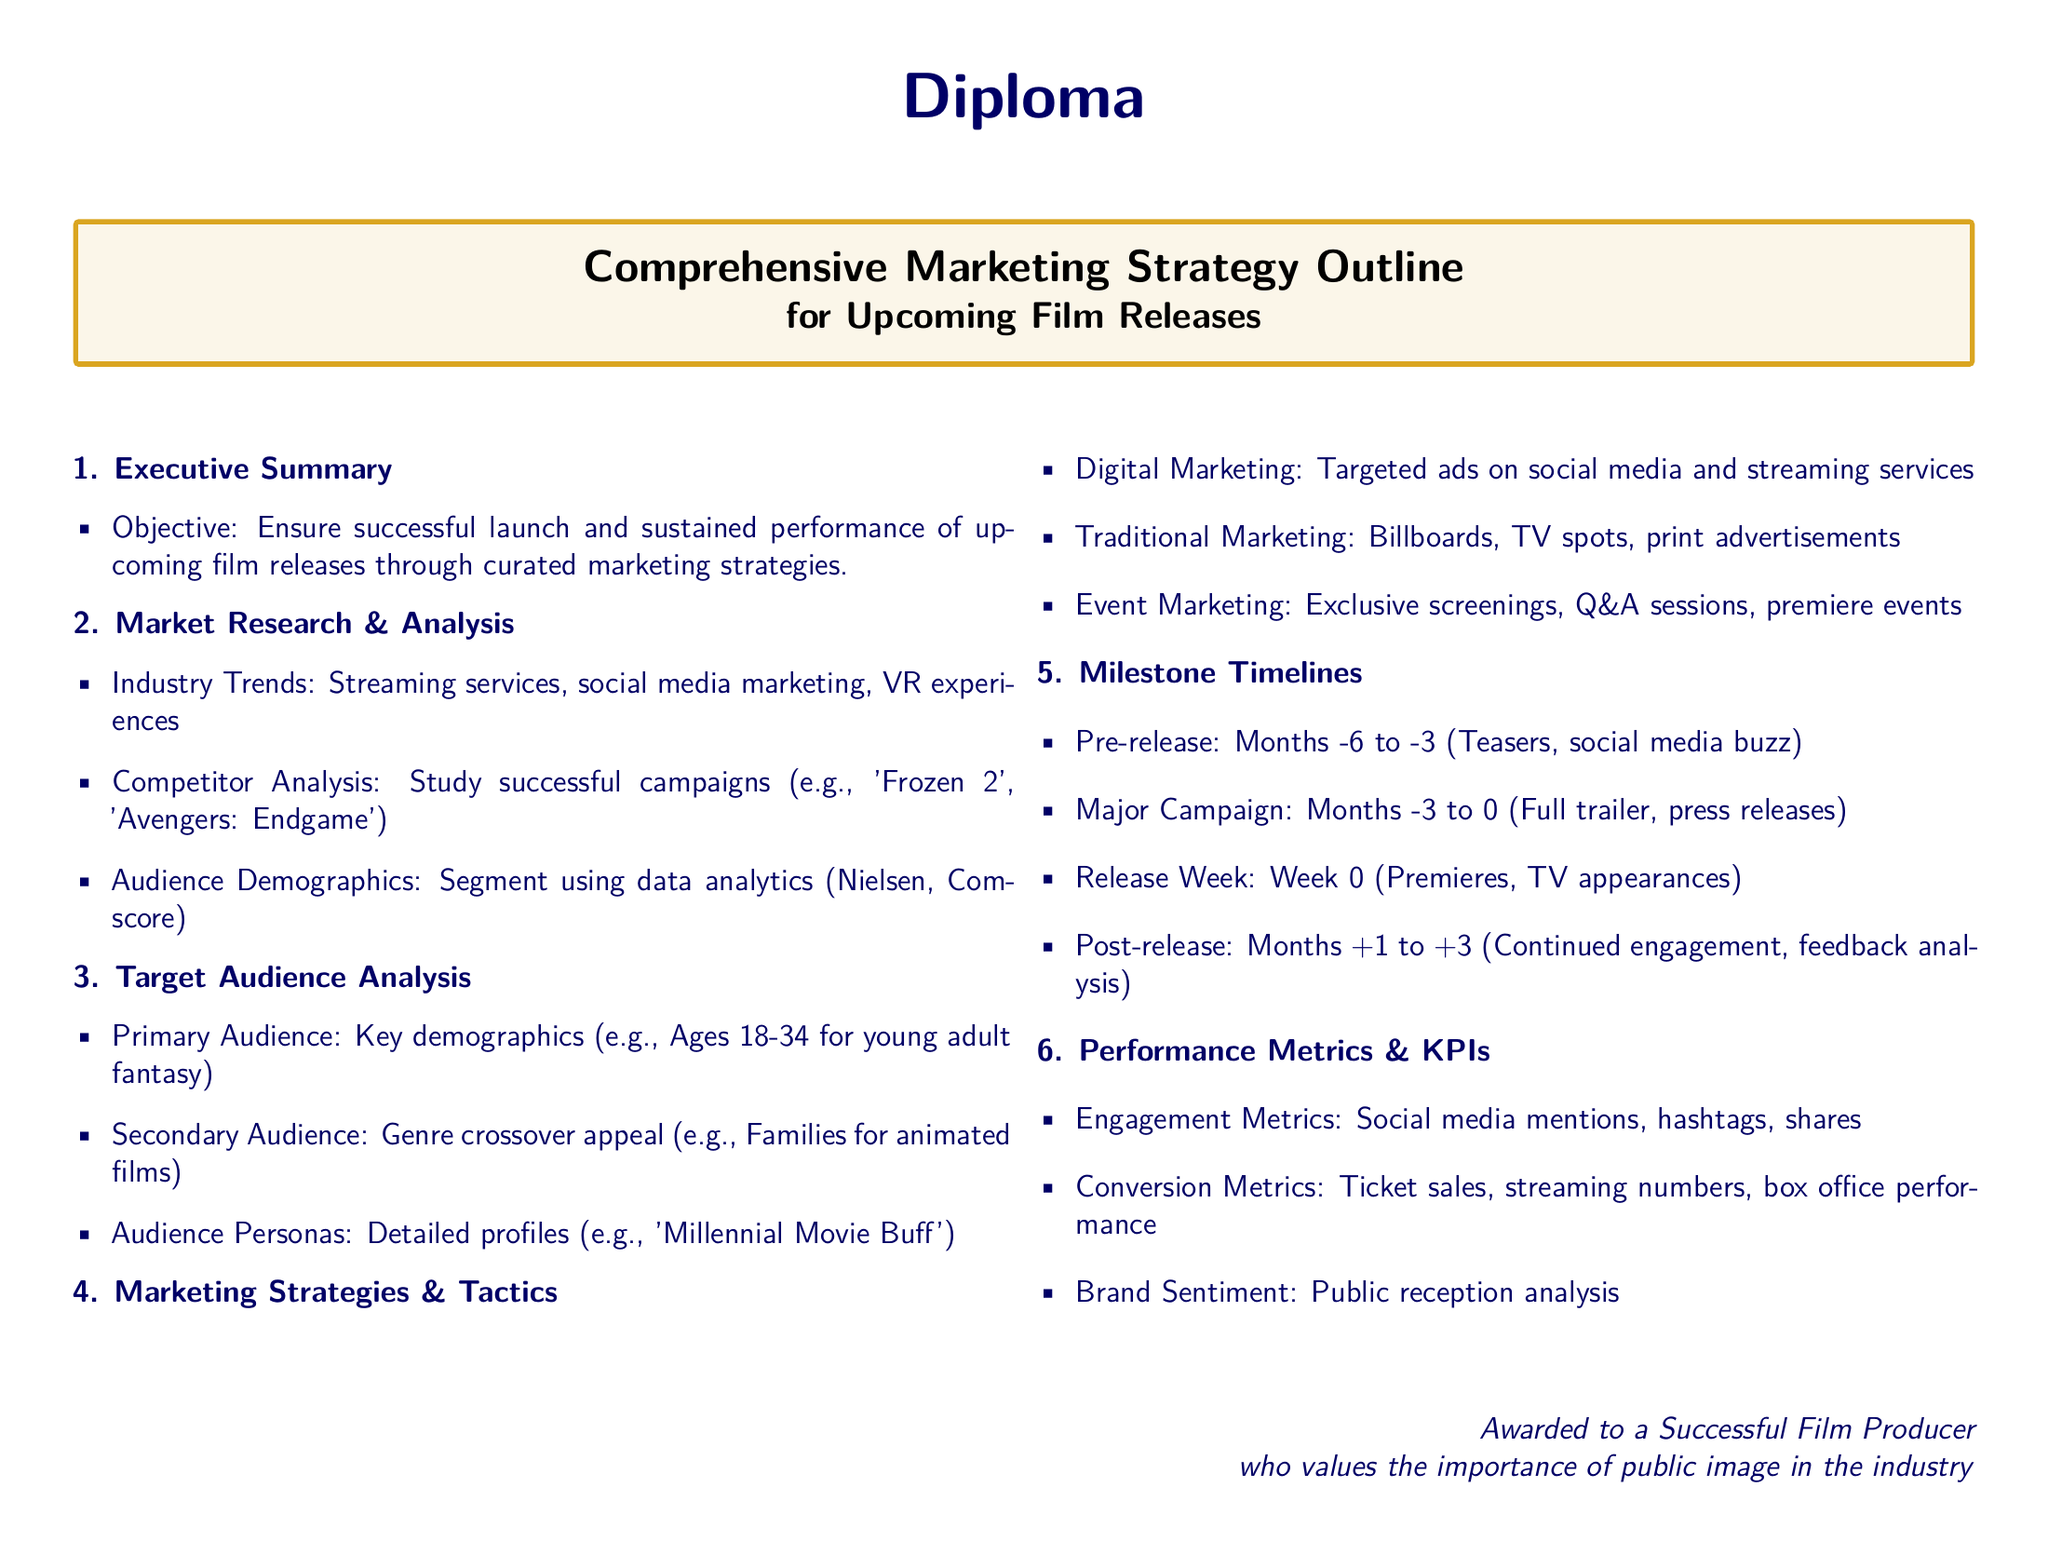What is the primary objective of the marketing strategy? The primary objective is to ensure successful launch and sustained performance of upcoming film releases through curated marketing strategies.
Answer: Ensure successful launch and sustained performance What age group is the primary audience for the young adult fantasy? The document specifies the primary audience to be ages 18-34 for young adult fantasy.
Answer: Ages 18-34 What type of marketing event is mentioned for audience engagement? The document lists exclusive screenings as one of the marketing event types for audience engagement.
Answer: Exclusive screenings How long is the pre-release marketing phase according to the milestone timelines? The pre-release marketing phase is identified as lasting from months -6 to -3.
Answer: Months -6 to -3 Which film is mentioned in the competitor analysis section? The film 'Avengers: Endgame' is cited as a successful campaign in the competitor analysis section.
Answer: Avengers: Endgame What is one of the performance metrics outlined in the document? Engagement Metrics, which include social media mentions, are one of the performance metrics outlined.
Answer: Engagement Metrics What is the time frame for the major marketing campaign? The major marketing campaign is set for months -3 to 0.
Answer: Months -3 to 0 What persona is discussed in the target audience analysis? The persona 'Millennial Movie Buff' is mentioned in the target audience analysis.
Answer: Millennial Movie Buff 